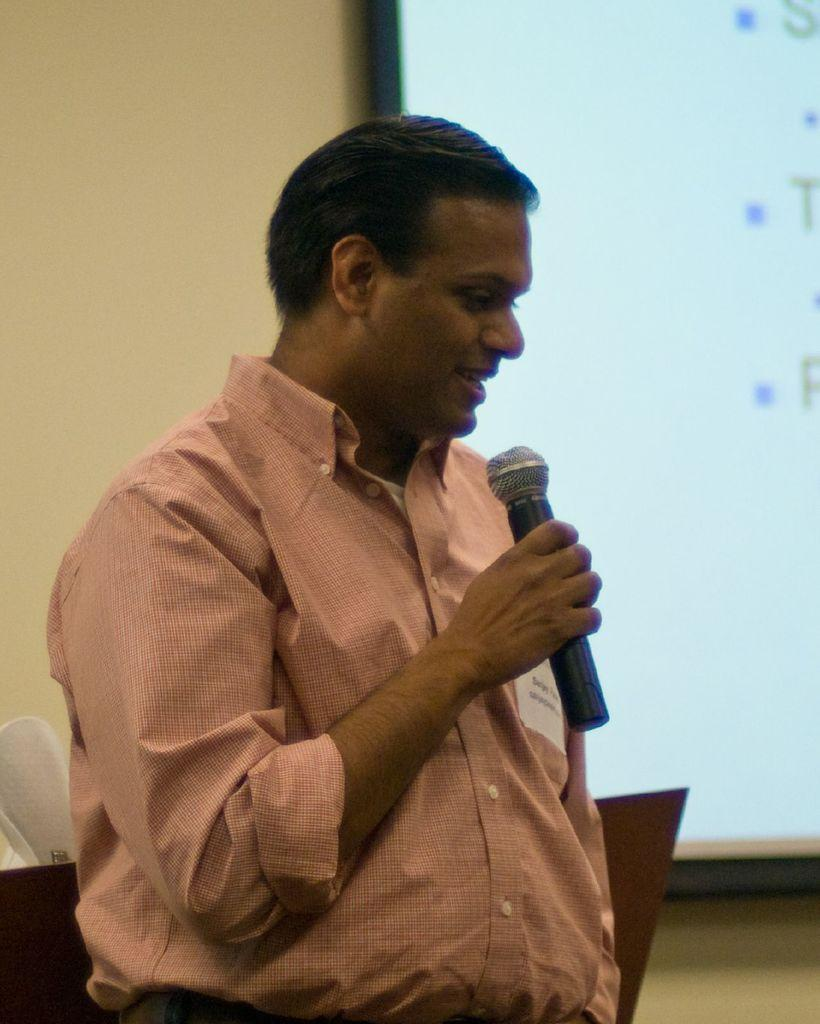What is the person in the image doing? The person is standing in the image and holding a mic. What object can be seen behind the person? There is a chair behind the person. What is hanging on the wall in the image? There is a screen hanging on the wall. Is there an umbrella visible in the image? No, there is no umbrella present in the image. How many visitors can be seen in the image? There is only one person visible in the image, so there is no visitor present. 